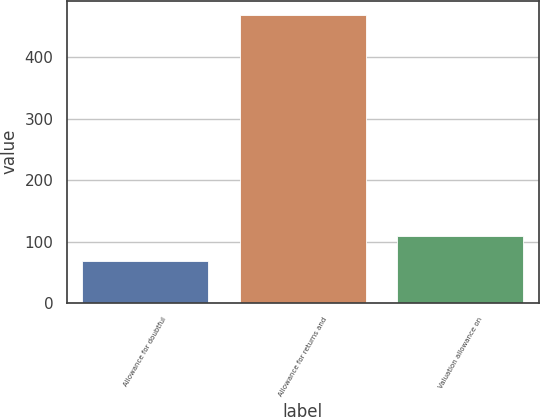Convert chart. <chart><loc_0><loc_0><loc_500><loc_500><bar_chart><fcel>Allowance for doubtful<fcel>Allowance for returns and<fcel>Valuation allowance on<nl><fcel>69<fcel>469<fcel>109<nl></chart> 